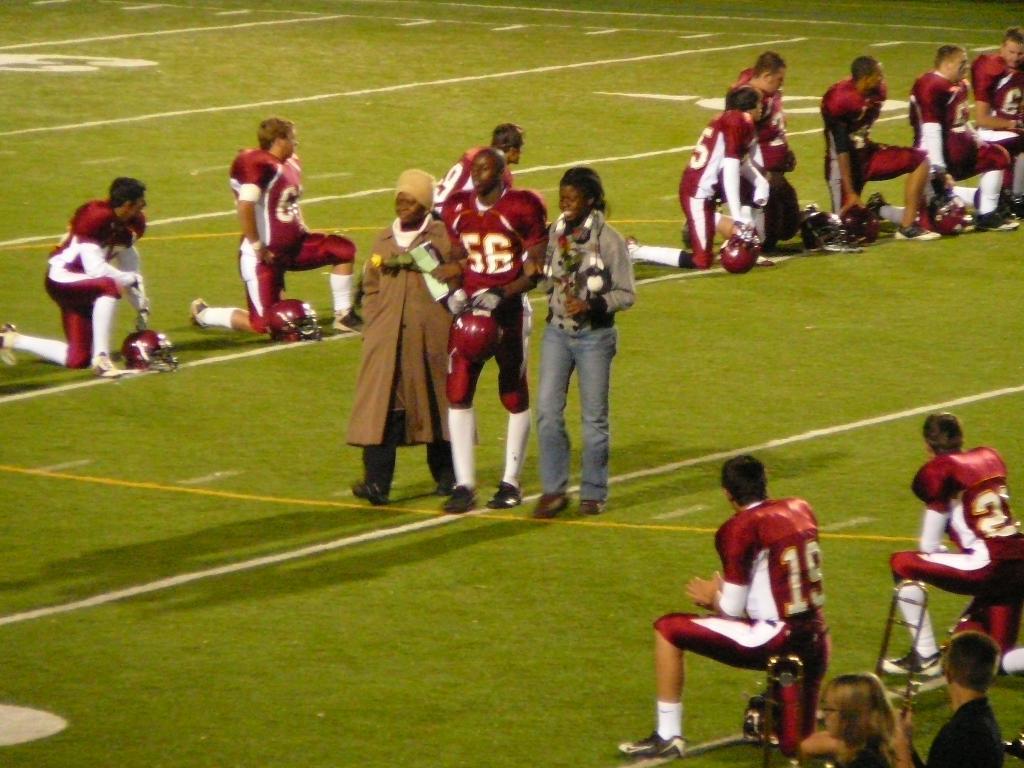Please provide a concise description of this image. In this image we can see many people. Some are having helmets. On the ground there is grass. 